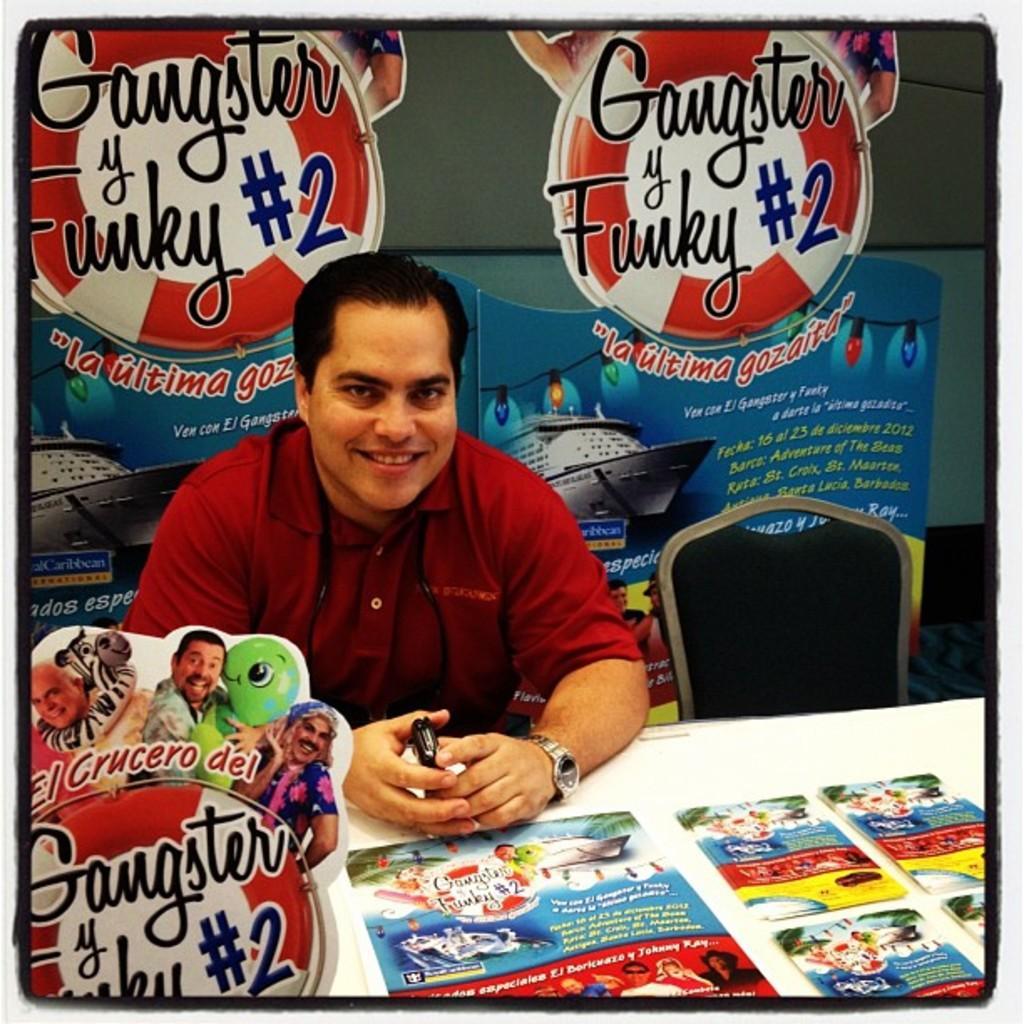Can you describe this image briefly? In the picture we can see a man sitting on the chair near the table, on the table, we can see some pamphlets and the man is holding a mobile phone and wearing a red T-shirt and just beside of him we can see two chairs which are black in color and in the background we can see some posters and advertisements on the wall. 